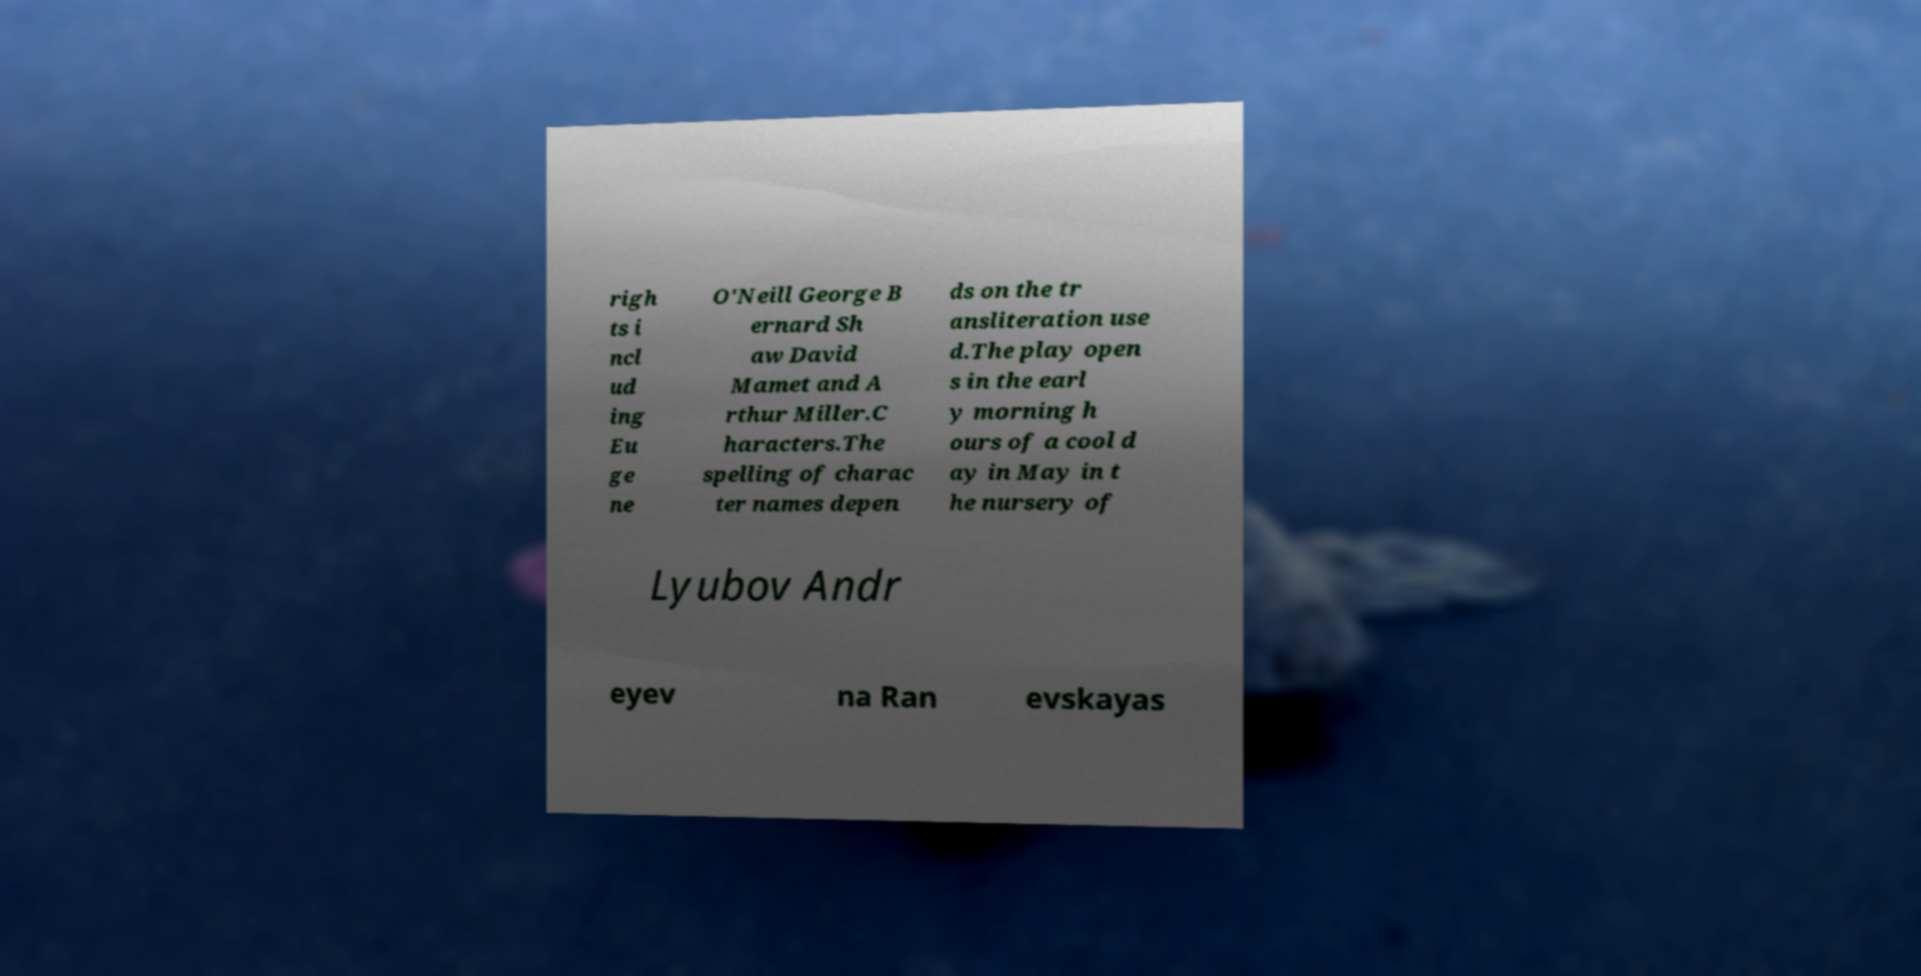There's text embedded in this image that I need extracted. Can you transcribe it verbatim? righ ts i ncl ud ing Eu ge ne O'Neill George B ernard Sh aw David Mamet and A rthur Miller.C haracters.The spelling of charac ter names depen ds on the tr ansliteration use d.The play open s in the earl y morning h ours of a cool d ay in May in t he nursery of Lyubov Andr eyev na Ran evskayas 